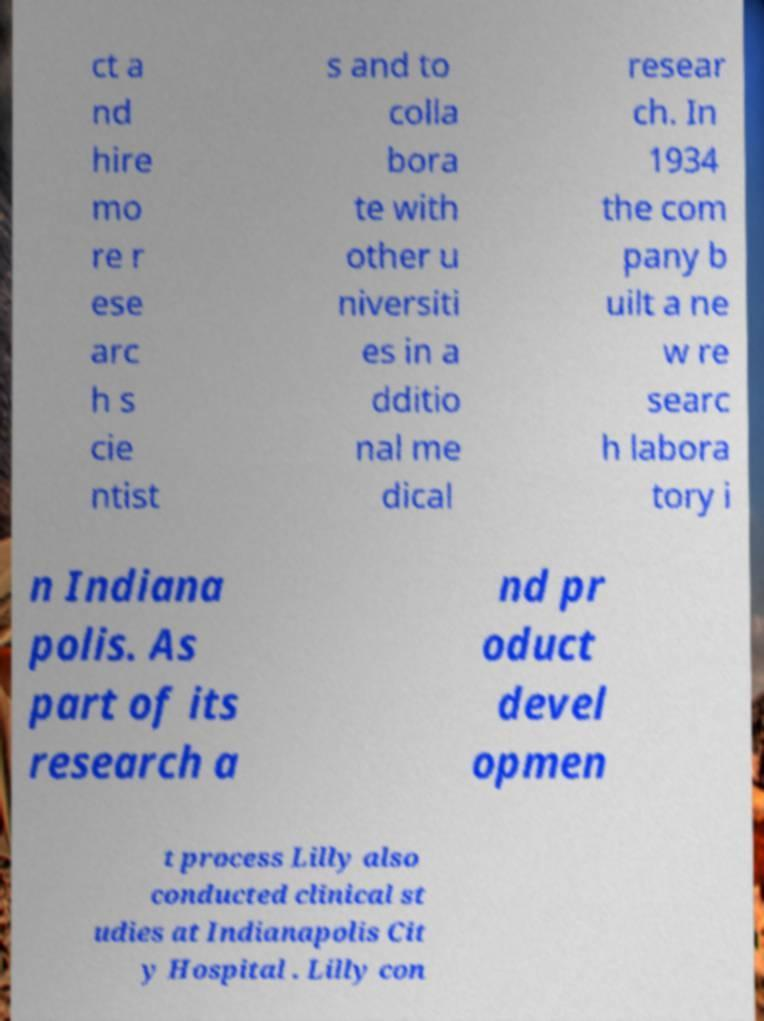For documentation purposes, I need the text within this image transcribed. Could you provide that? ct a nd hire mo re r ese arc h s cie ntist s and to colla bora te with other u niversiti es in a dditio nal me dical resear ch. In 1934 the com pany b uilt a ne w re searc h labora tory i n Indiana polis. As part of its research a nd pr oduct devel opmen t process Lilly also conducted clinical st udies at Indianapolis Cit y Hospital . Lilly con 